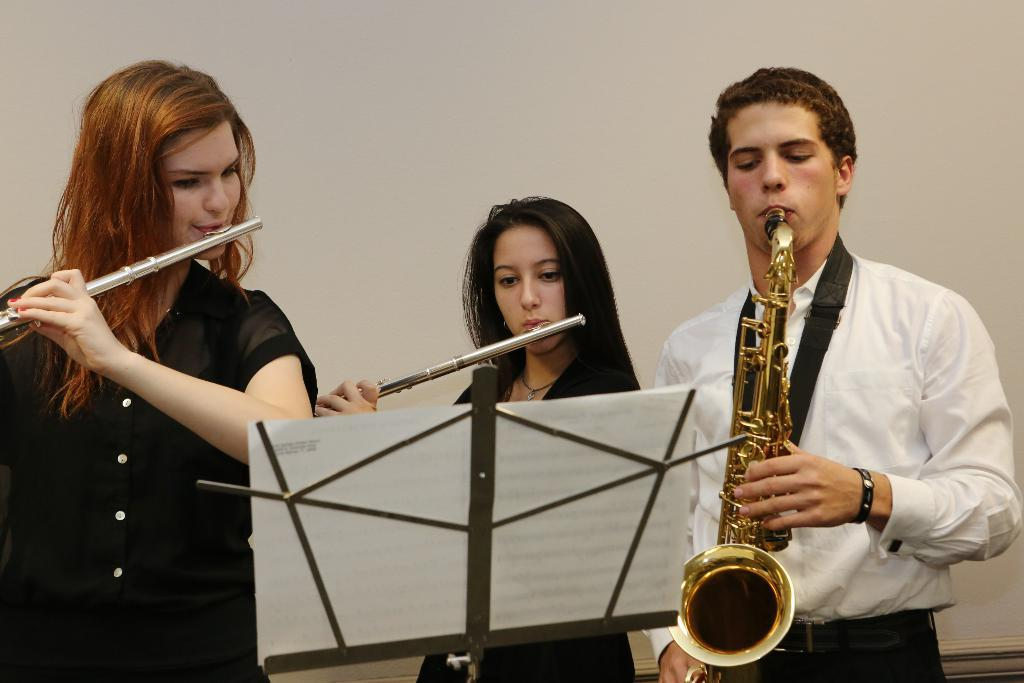How many people are playing musical instruments in the image? There are three persons playing musical instruments in the image. What else can be seen in the image besides the people playing instruments? There are papers on a stand in the image. What is the color of the background in the image? The background of the image is white in color. Can you tell me how many toes are visible on the turkey in the image? There is no turkey present in the image, and therefore no toes can be observed. What type of record is being played by the musicians in the image? There is no record player or record visible in the image; only the people playing musical instruments and the papers on a stand are present. 